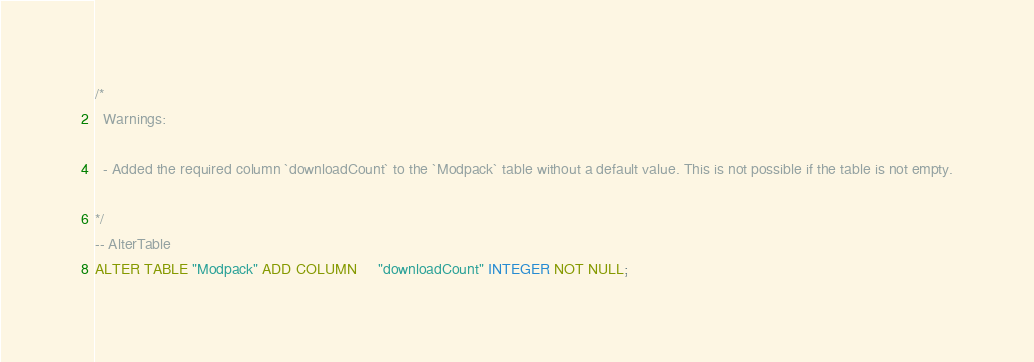Convert code to text. <code><loc_0><loc_0><loc_500><loc_500><_SQL_>/*
  Warnings:

  - Added the required column `downloadCount` to the `Modpack` table without a default value. This is not possible if the table is not empty.

*/
-- AlterTable
ALTER TABLE "Modpack" ADD COLUMN     "downloadCount" INTEGER NOT NULL;
</code> 